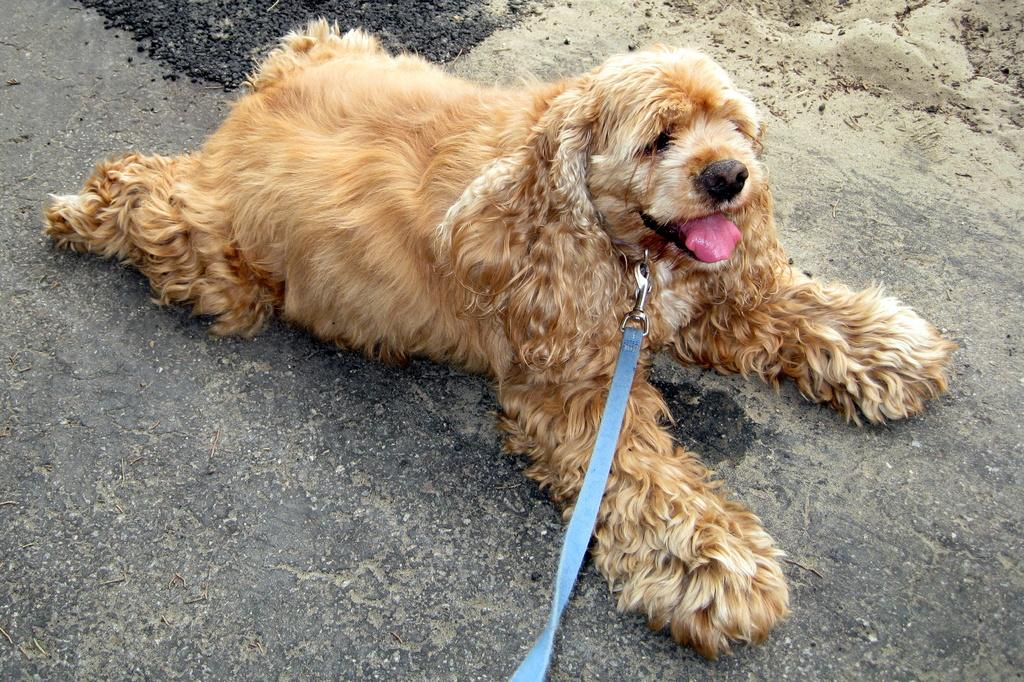What type of animal is present in the image? There is a dog in the image. What colors can be seen on the dog? The dog is brown, cream, and black in color. What position is the dog in? The dog is lying on the ground. What other object can be seen in the image? There is a blue-colored belt visible in the image. How does the dog celebrate its birthday in the image? There is no indication of a birthday celebration in the image, and the dog's age is not mentioned. 